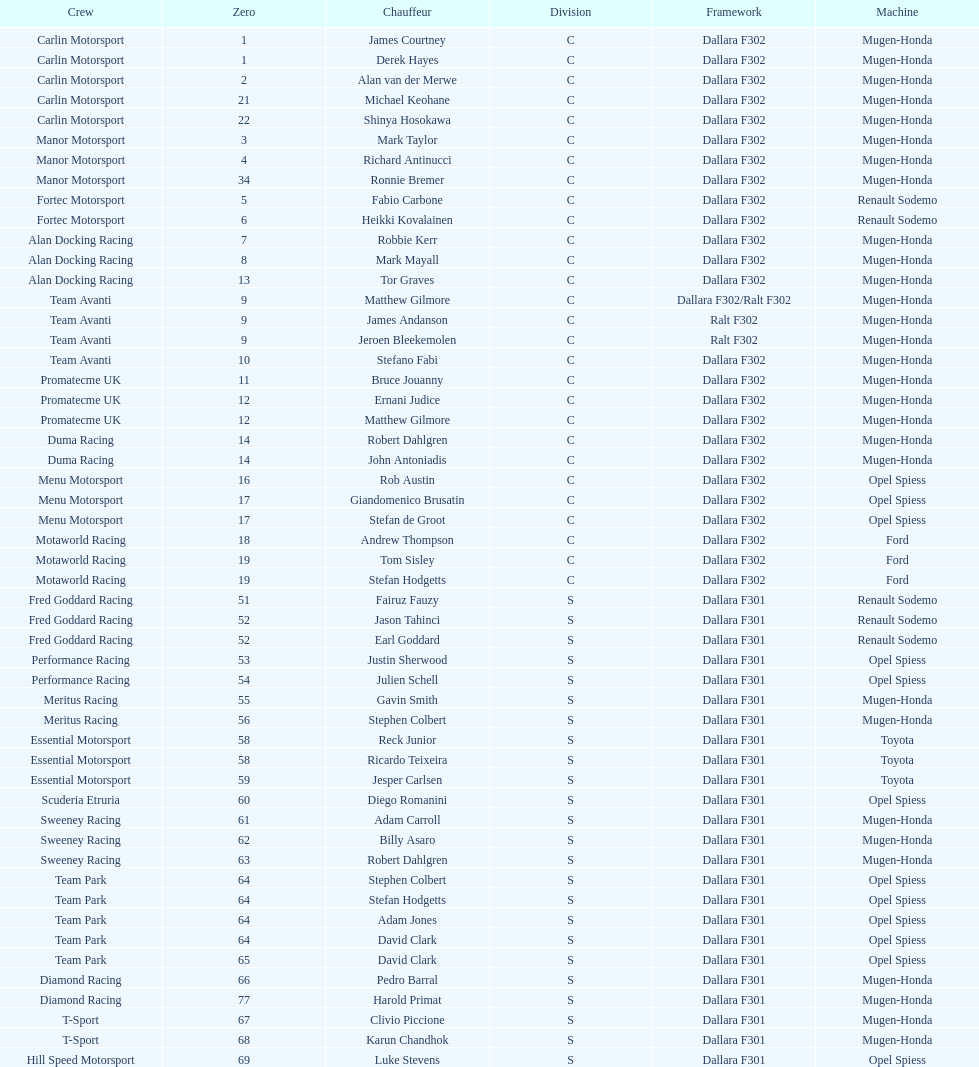What team is listed above diamond racing? Team Park. 